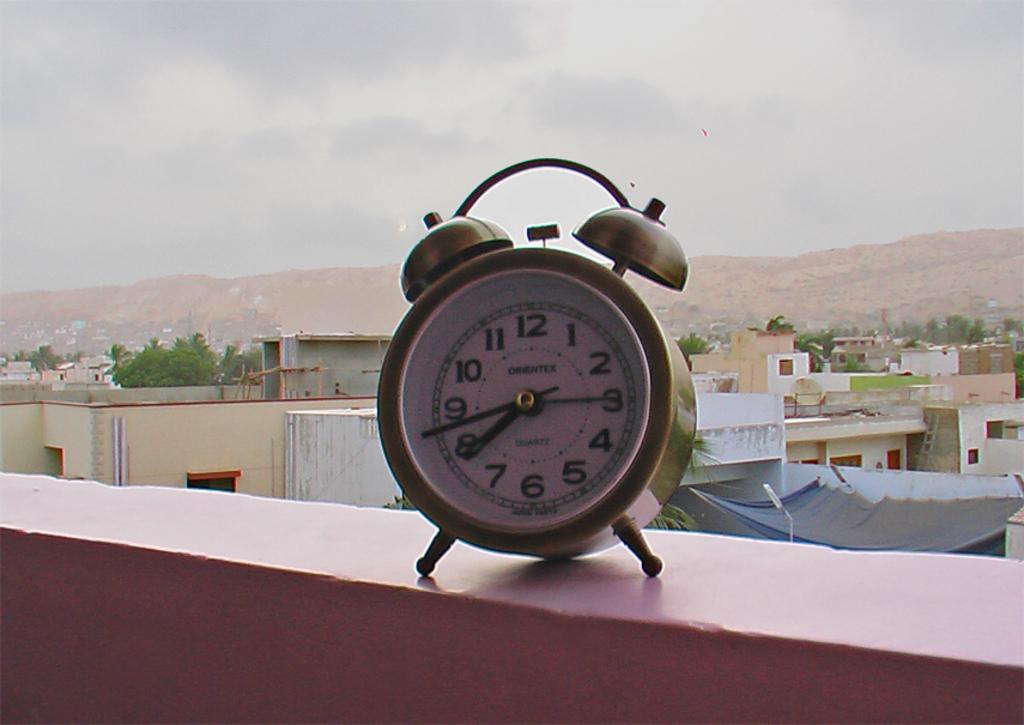What number can be seen?
Provide a short and direct response. 1-12. What time is it?
Give a very brief answer. 7:43. 